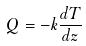<formula> <loc_0><loc_0><loc_500><loc_500>Q = - k \frac { d T } { d z }</formula> 